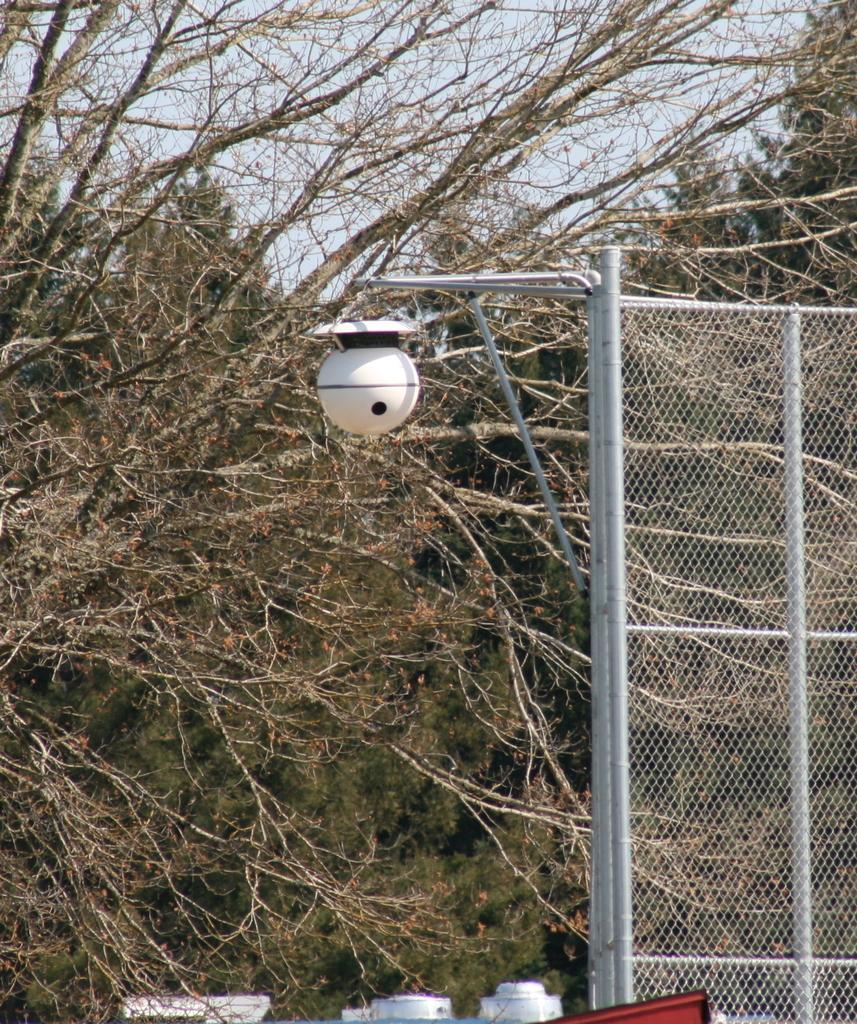What type of barrier is present in the image? There is a netted fencing in the image. What is attached to the netted fencing? There is a pole with a lamp post attached to the netted fencing. What can be seen in the background of the image? Trees are visible in the background of the image. How long does it take for the glove to fall from the top of the pole in the image? There is no glove present in the image, so it is not possible to determine how long it would take for a glove to fall from the top of the pole. 